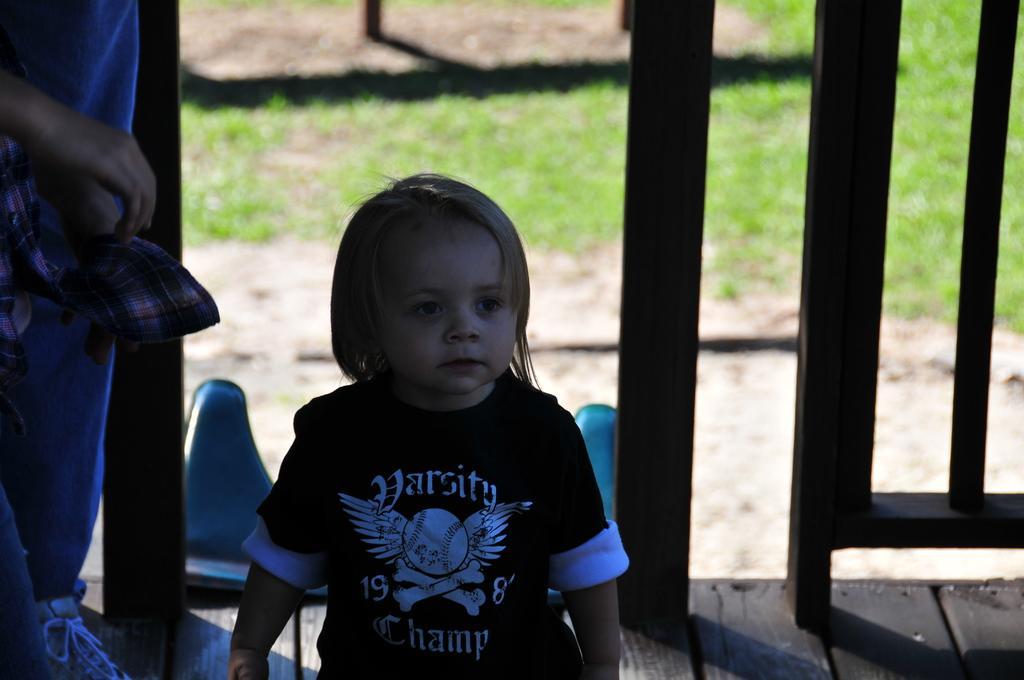In one or two sentences, can you explain what this image depicts? In this image we can see two persons. One boy is wearing black t shirt. In the background, we can see a barricade. 